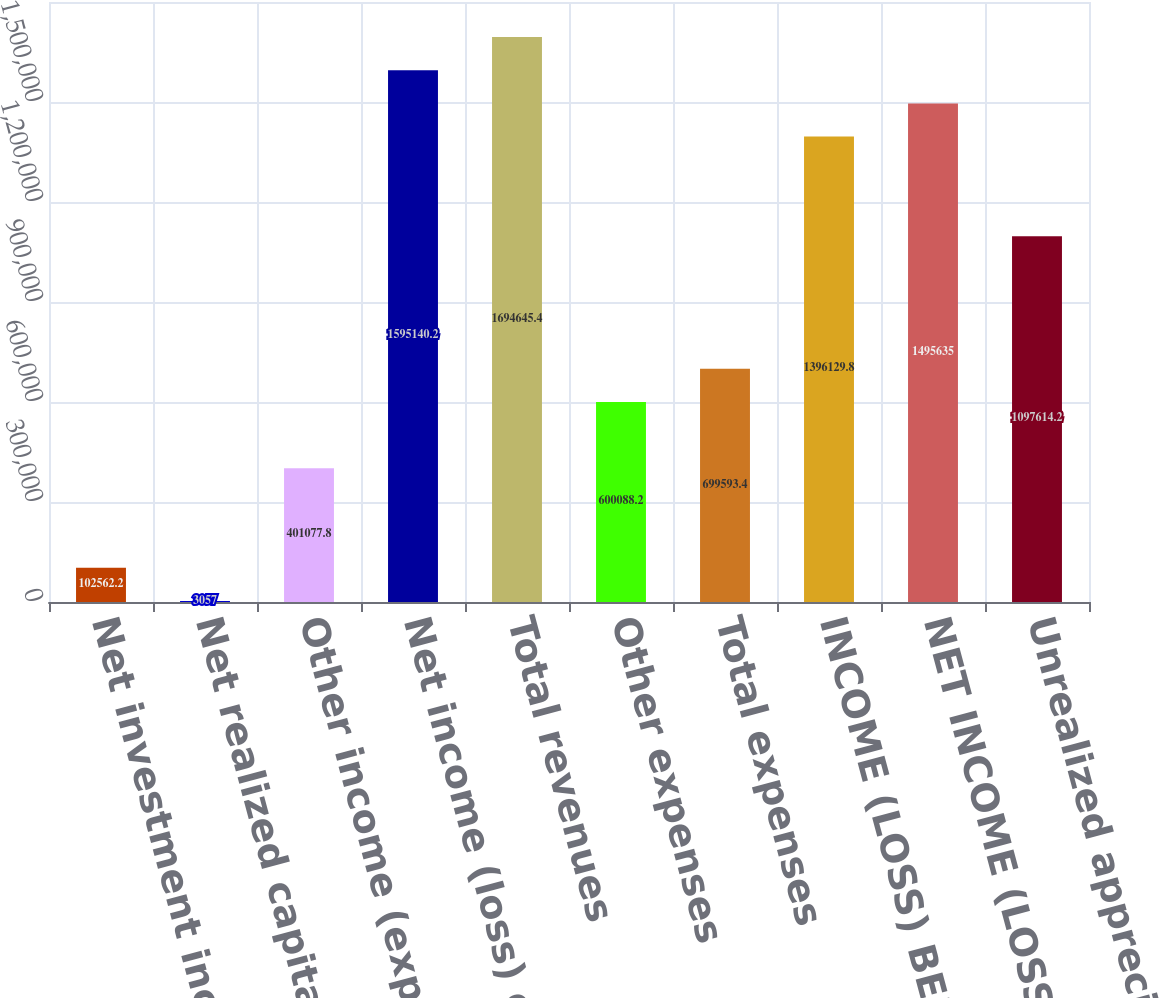Convert chart to OTSL. <chart><loc_0><loc_0><loc_500><loc_500><bar_chart><fcel>Net investment income<fcel>Net realized capital gains<fcel>Other income (expense)<fcel>Net income (loss) of<fcel>Total revenues<fcel>Other expenses<fcel>Total expenses<fcel>INCOME (LOSS) BEFORE TAXES<fcel>NET INCOME (LOSS)<fcel>Unrealized appreciation<nl><fcel>102562<fcel>3057<fcel>401078<fcel>1.59514e+06<fcel>1.69465e+06<fcel>600088<fcel>699593<fcel>1.39613e+06<fcel>1.49564e+06<fcel>1.09761e+06<nl></chart> 